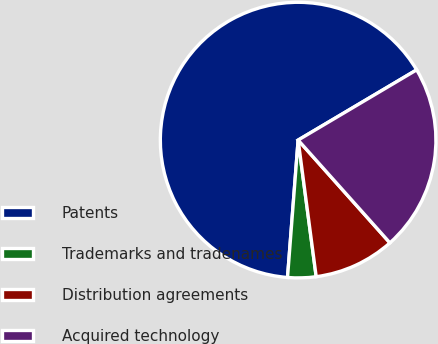Convert chart. <chart><loc_0><loc_0><loc_500><loc_500><pie_chart><fcel>Patents<fcel>Trademarks and tradenames<fcel>Distribution agreements<fcel>Acquired technology<nl><fcel>65.26%<fcel>3.32%<fcel>9.51%<fcel>21.91%<nl></chart> 